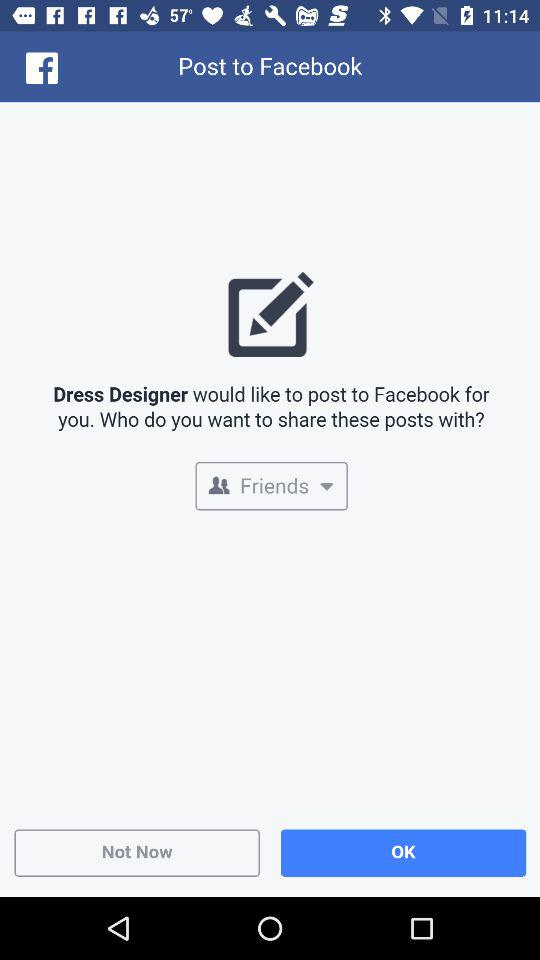What is the user's name?
When the provided information is insufficient, respond with <no answer>. <no answer> 